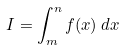Convert formula to latex. <formula><loc_0><loc_0><loc_500><loc_500>I = \int _ { m } ^ { n } f ( x ) \, d x</formula> 